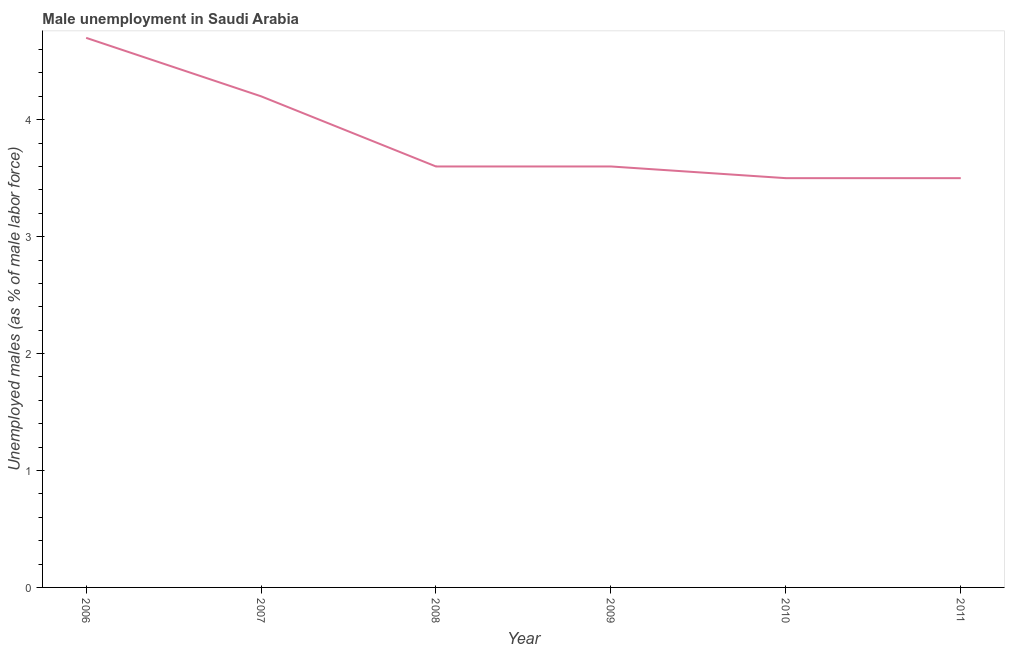What is the unemployed males population in 2011?
Keep it short and to the point. 3.5. Across all years, what is the maximum unemployed males population?
Your answer should be compact. 4.7. Across all years, what is the minimum unemployed males population?
Provide a short and direct response. 3.5. What is the sum of the unemployed males population?
Offer a very short reply. 23.1. What is the difference between the unemployed males population in 2007 and 2009?
Provide a succinct answer. 0.6. What is the average unemployed males population per year?
Provide a short and direct response. 3.85. What is the median unemployed males population?
Make the answer very short. 3.6. Do a majority of the years between 2006 and 2007 (inclusive) have unemployed males population greater than 4.2 %?
Your response must be concise. No. What is the ratio of the unemployed males population in 2008 to that in 2010?
Give a very brief answer. 1.03. Is the difference between the unemployed males population in 2006 and 2010 greater than the difference between any two years?
Ensure brevity in your answer.  Yes. What is the difference between the highest and the second highest unemployed males population?
Your answer should be very brief. 0.5. Is the sum of the unemployed males population in 2006 and 2010 greater than the maximum unemployed males population across all years?
Offer a terse response. Yes. What is the difference between the highest and the lowest unemployed males population?
Your answer should be very brief. 1.2. How many lines are there?
Keep it short and to the point. 1. How many years are there in the graph?
Make the answer very short. 6. What is the difference between two consecutive major ticks on the Y-axis?
Your response must be concise. 1. Are the values on the major ticks of Y-axis written in scientific E-notation?
Offer a very short reply. No. Does the graph contain any zero values?
Your answer should be compact. No. Does the graph contain grids?
Provide a succinct answer. No. What is the title of the graph?
Your response must be concise. Male unemployment in Saudi Arabia. What is the label or title of the X-axis?
Keep it short and to the point. Year. What is the label or title of the Y-axis?
Your response must be concise. Unemployed males (as % of male labor force). What is the Unemployed males (as % of male labor force) of 2006?
Your answer should be compact. 4.7. What is the Unemployed males (as % of male labor force) of 2007?
Give a very brief answer. 4.2. What is the Unemployed males (as % of male labor force) in 2008?
Offer a terse response. 3.6. What is the Unemployed males (as % of male labor force) in 2009?
Ensure brevity in your answer.  3.6. What is the Unemployed males (as % of male labor force) in 2010?
Give a very brief answer. 3.5. What is the difference between the Unemployed males (as % of male labor force) in 2006 and 2009?
Offer a terse response. 1.1. What is the difference between the Unemployed males (as % of male labor force) in 2007 and 2008?
Provide a short and direct response. 0.6. What is the difference between the Unemployed males (as % of male labor force) in 2008 and 2011?
Provide a short and direct response. 0.1. What is the difference between the Unemployed males (as % of male labor force) in 2009 and 2010?
Your answer should be very brief. 0.1. What is the difference between the Unemployed males (as % of male labor force) in 2009 and 2011?
Your answer should be compact. 0.1. What is the difference between the Unemployed males (as % of male labor force) in 2010 and 2011?
Offer a very short reply. 0. What is the ratio of the Unemployed males (as % of male labor force) in 2006 to that in 2007?
Provide a short and direct response. 1.12. What is the ratio of the Unemployed males (as % of male labor force) in 2006 to that in 2008?
Keep it short and to the point. 1.31. What is the ratio of the Unemployed males (as % of male labor force) in 2006 to that in 2009?
Ensure brevity in your answer.  1.31. What is the ratio of the Unemployed males (as % of male labor force) in 2006 to that in 2010?
Your answer should be very brief. 1.34. What is the ratio of the Unemployed males (as % of male labor force) in 2006 to that in 2011?
Your answer should be compact. 1.34. What is the ratio of the Unemployed males (as % of male labor force) in 2007 to that in 2008?
Make the answer very short. 1.17. What is the ratio of the Unemployed males (as % of male labor force) in 2007 to that in 2009?
Your response must be concise. 1.17. What is the ratio of the Unemployed males (as % of male labor force) in 2007 to that in 2010?
Ensure brevity in your answer.  1.2. What is the ratio of the Unemployed males (as % of male labor force) in 2007 to that in 2011?
Keep it short and to the point. 1.2. What is the ratio of the Unemployed males (as % of male labor force) in 2009 to that in 2011?
Offer a very short reply. 1.03. What is the ratio of the Unemployed males (as % of male labor force) in 2010 to that in 2011?
Keep it short and to the point. 1. 